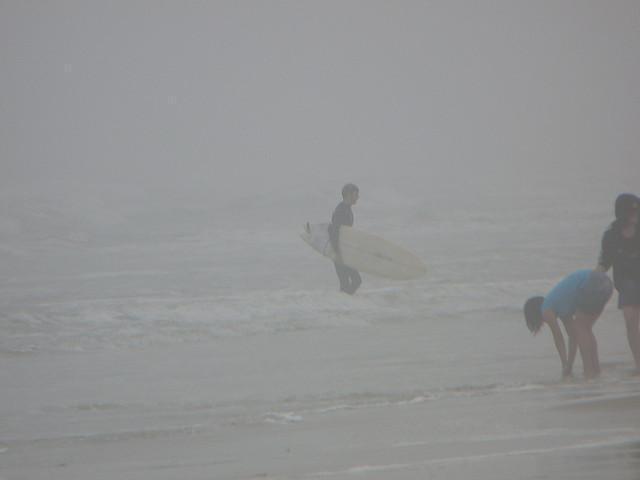How many people?
Give a very brief answer. 3. How many people are in the picture?
Give a very brief answer. 2. 